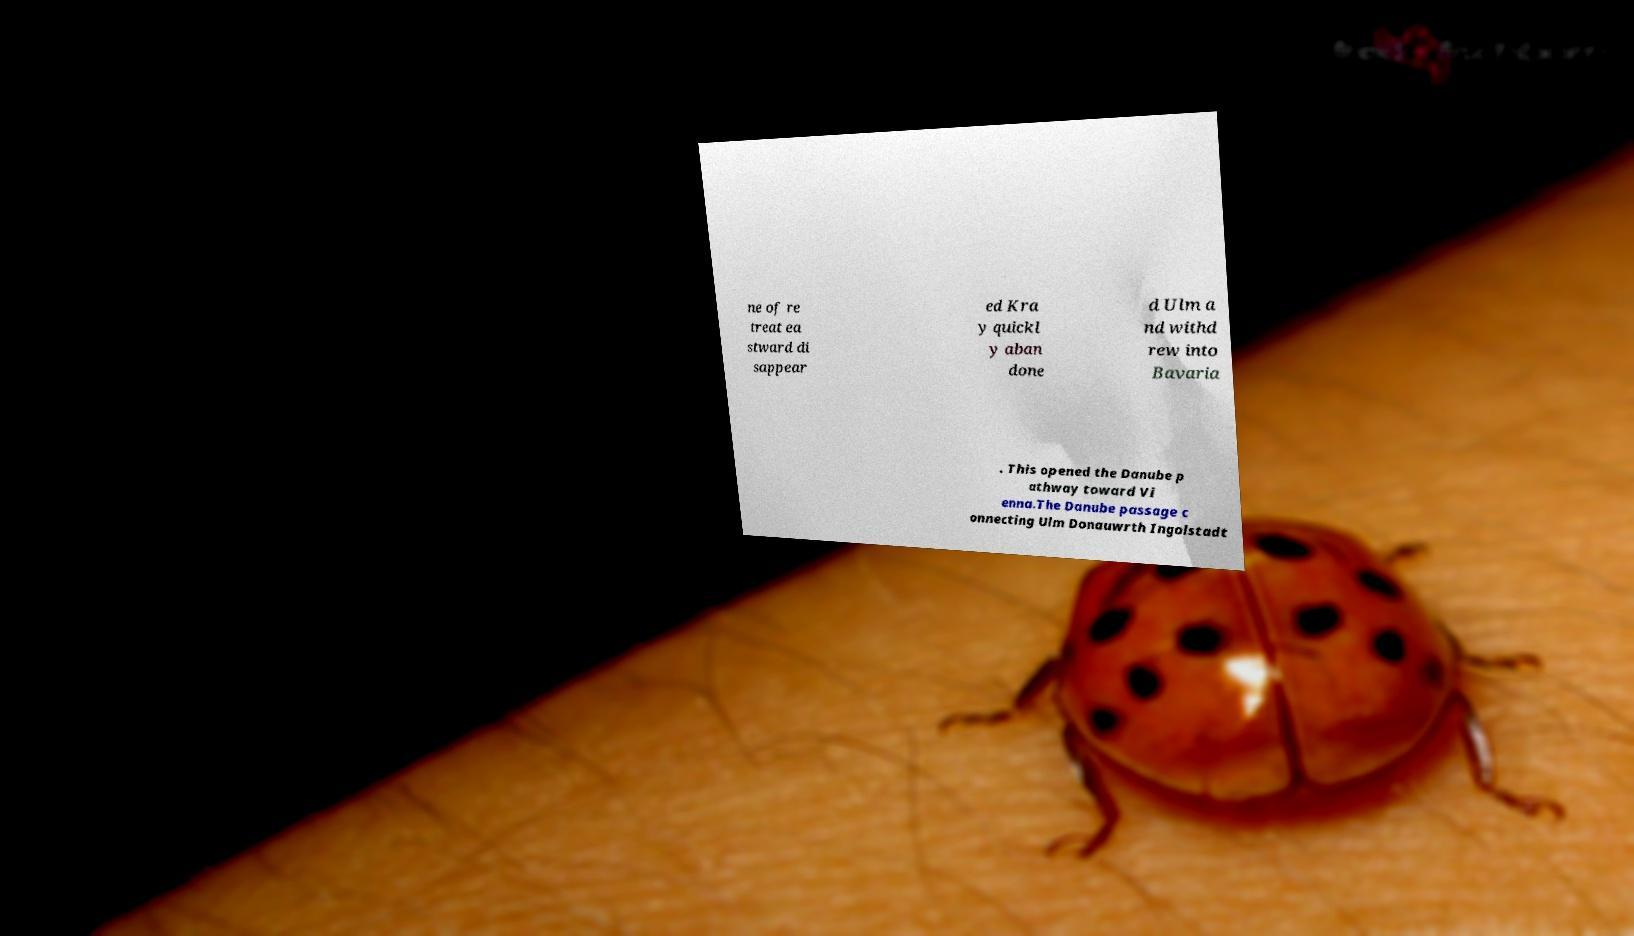Could you extract and type out the text from this image? ne of re treat ea stward di sappear ed Kra y quickl y aban done d Ulm a nd withd rew into Bavaria . This opened the Danube p athway toward Vi enna.The Danube passage c onnecting Ulm Donauwrth Ingolstadt 